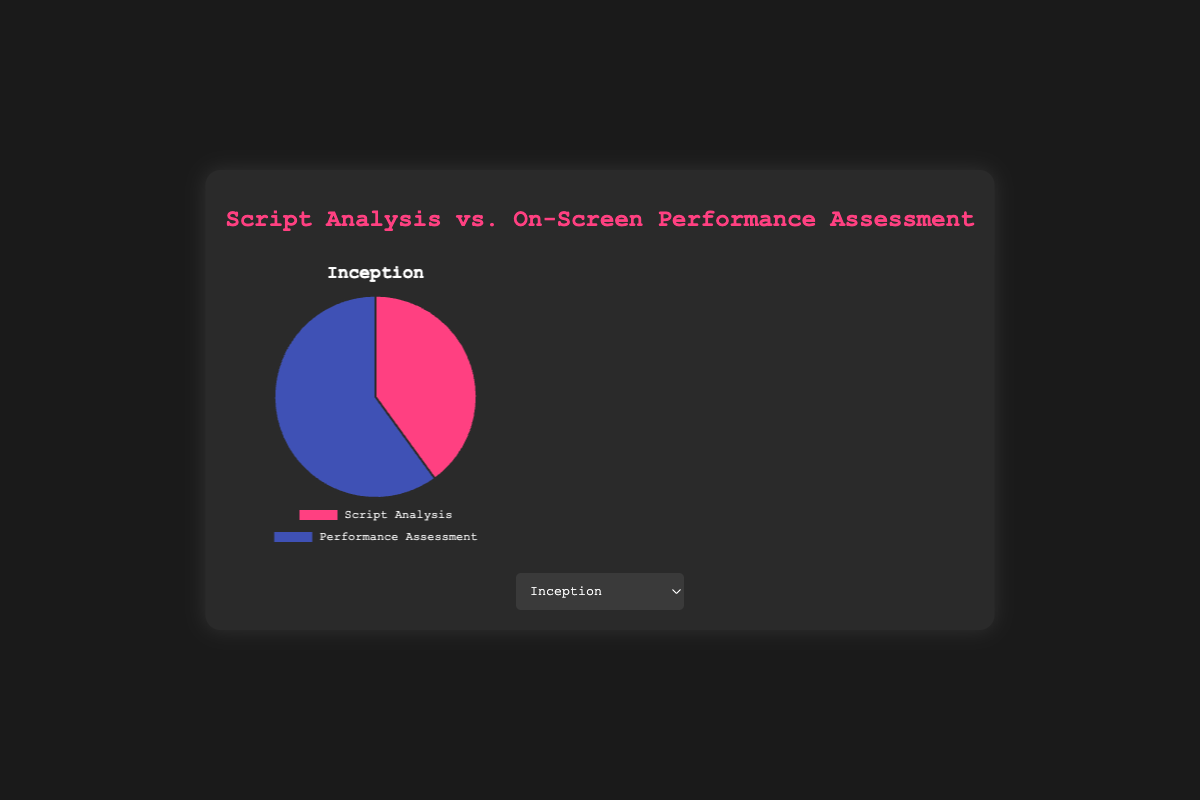What's the ratio of time spent on script analysis to performance assessment for "Inception"? For "Inception", the time spent on script analysis is 40 and on performance assessment is 60. The ratio of script analysis to performance assessment is 40:60. Simplifying this ratio by dividing both numbers by their greatest common divisor (20), we get 2:3.
Answer: 2:3 Which film had the highest percentage of time spent on performance assessment? Among the films listed: Inception (60%), The Godfather (65%), Pulp Fiction (55%), The Dark Knight (50%), and Schindler's List (70%), Schindler's List had the highest percentage of time spent on performance assessment, at 70%.
Answer: Schindler's List How much more time, in percentage points, was spent on script analysis for "The Dark Knight" compared to "Schindler's List"? "The Dark Knight" had 50% spent on script analysis while "Schindler's List" had 30%. The difference is 50% - 30% = 20 percentage points more for "The Dark Knight".
Answer: 20 Which film had an equal split between script analysis and performance assessment? Checking each film's percentages, "The Dark Knight" had an equal split with 50% on script analysis and 50% on performance assessment.
Answer: The Dark Knight What is the average percentage of time spent on script analysis across all films? To find the average, sum the percentages spent on script analysis for all films and divide by the number of films: (40 + 35 + 45 + 50 + 30) / 5 = 200 / 5 = 40%.
Answer: 40% Which color represents performance assessment in the pie chart? The visual attributes show that the color for performance assessment across all pie charts is blue.
Answer: Blue Between "Inception" and "Pulp Fiction," which film had a higher percentage of time spent on script analysis? By how much? "Inception" had 40% spent on script analysis, while "Pulp Fiction" had 45%. "Pulp Fiction" had a higher percentage by 45% - 40% = 5%.
Answer: Pulp Fiction, 5 What's the combined percentage of time spent on performance assessment for "The Godfather" and "Pulp Fiction"? Both films' performance assessment percentages are 65% and 55%, respectively. Adding them together gives 65% + 55% = 120%.
Answer: 120% Which film had the lowest percentage of time spent on script analysis, and what was this percentage? Comparing script analysis percentages: Inception (40%), The Godfather (35%), Pulp Fiction (45%), The Dark Knight (50%), and Schindler's List (30%). "Schindler's List" had the lowest at 30%.
Answer: Schindler's List, 30% 